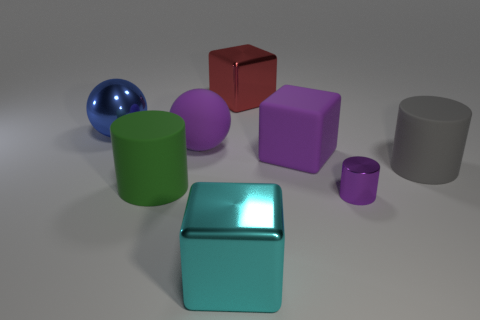Add 1 metallic objects. How many objects exist? 9 Subtract all purple cylinders. How many cylinders are left? 2 Subtract all large green matte cylinders. How many cylinders are left? 2 Subtract all balls. How many objects are left? 6 Subtract all big metal balls. Subtract all red metallic things. How many objects are left? 6 Add 6 purple blocks. How many purple blocks are left? 7 Add 5 large metallic spheres. How many large metallic spheres exist? 6 Subtract 0 red spheres. How many objects are left? 8 Subtract 2 cubes. How many cubes are left? 1 Subtract all brown cylinders. Subtract all blue blocks. How many cylinders are left? 3 